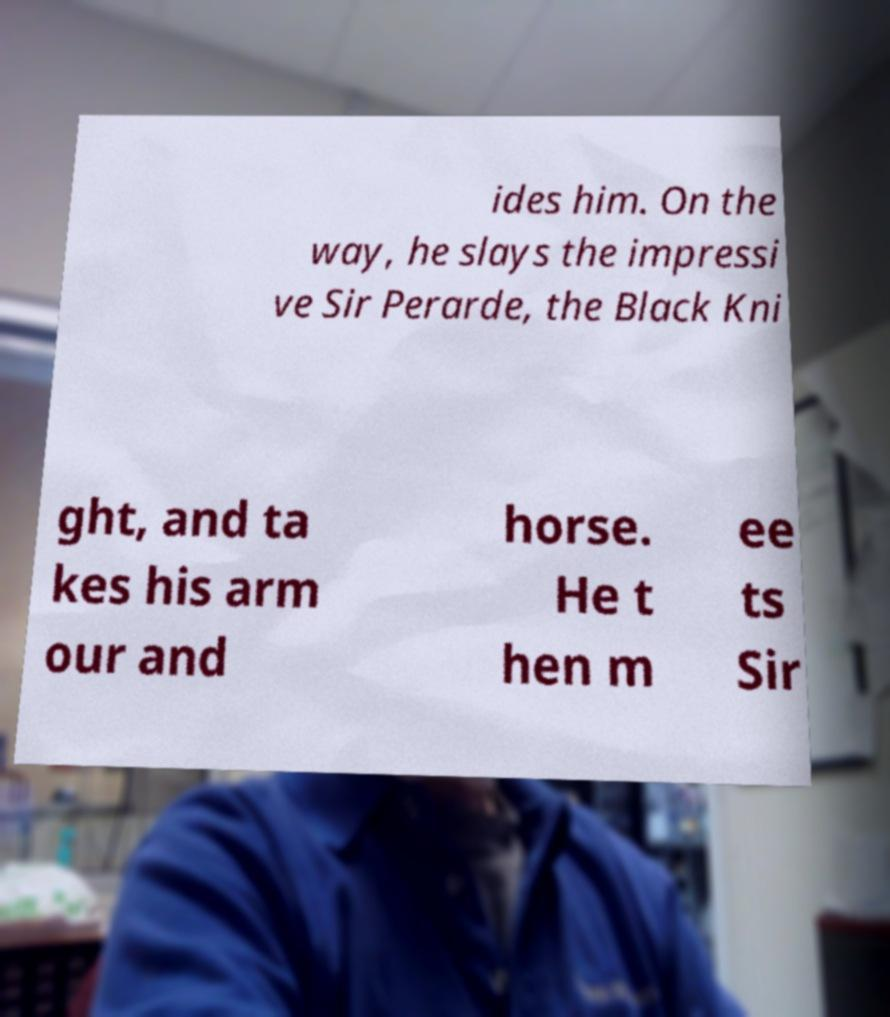What messages or text are displayed in this image? I need them in a readable, typed format. ides him. On the way, he slays the impressi ve Sir Perarde, the Black Kni ght, and ta kes his arm our and horse. He t hen m ee ts Sir 